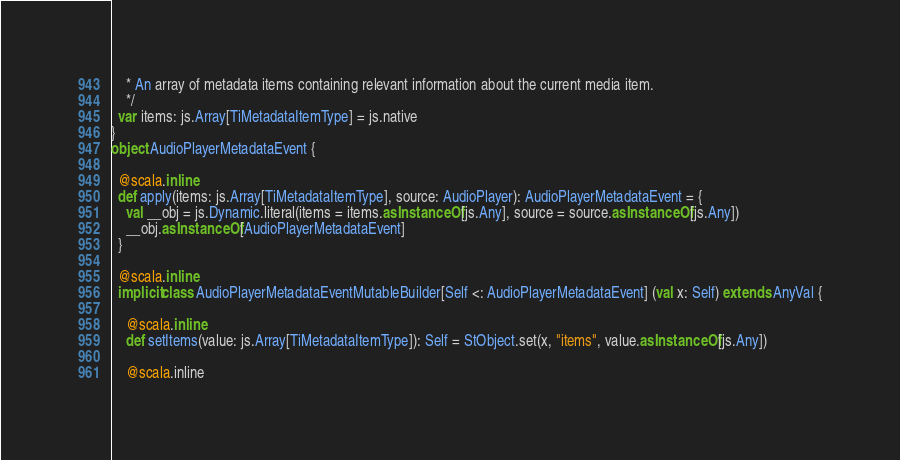Convert code to text. <code><loc_0><loc_0><loc_500><loc_500><_Scala_>    * An array of metadata items containing relevant information about the current media item.
    */
  var items: js.Array[TiMetadataItemType] = js.native
}
object AudioPlayerMetadataEvent {
  
  @scala.inline
  def apply(items: js.Array[TiMetadataItemType], source: AudioPlayer): AudioPlayerMetadataEvent = {
    val __obj = js.Dynamic.literal(items = items.asInstanceOf[js.Any], source = source.asInstanceOf[js.Any])
    __obj.asInstanceOf[AudioPlayerMetadataEvent]
  }
  
  @scala.inline
  implicit class AudioPlayerMetadataEventMutableBuilder[Self <: AudioPlayerMetadataEvent] (val x: Self) extends AnyVal {
    
    @scala.inline
    def setItems(value: js.Array[TiMetadataItemType]): Self = StObject.set(x, "items", value.asInstanceOf[js.Any])
    
    @scala.inline</code> 